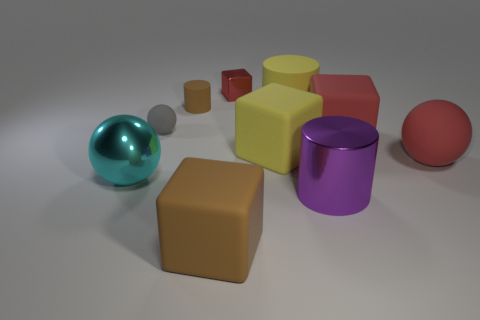Subtract all yellow rubber cubes. How many cubes are left? 3 Subtract all red blocks. How many blocks are left? 2 Subtract 3 cubes. How many cubes are left? 1 Add 6 big brown objects. How many big brown objects are left? 7 Add 5 red cubes. How many red cubes exist? 7 Subtract 1 purple cylinders. How many objects are left? 9 Subtract all cylinders. How many objects are left? 7 Subtract all red cylinders. Subtract all green balls. How many cylinders are left? 3 Subtract all yellow spheres. How many yellow cylinders are left? 1 Subtract all gray cylinders. Subtract all red matte things. How many objects are left? 8 